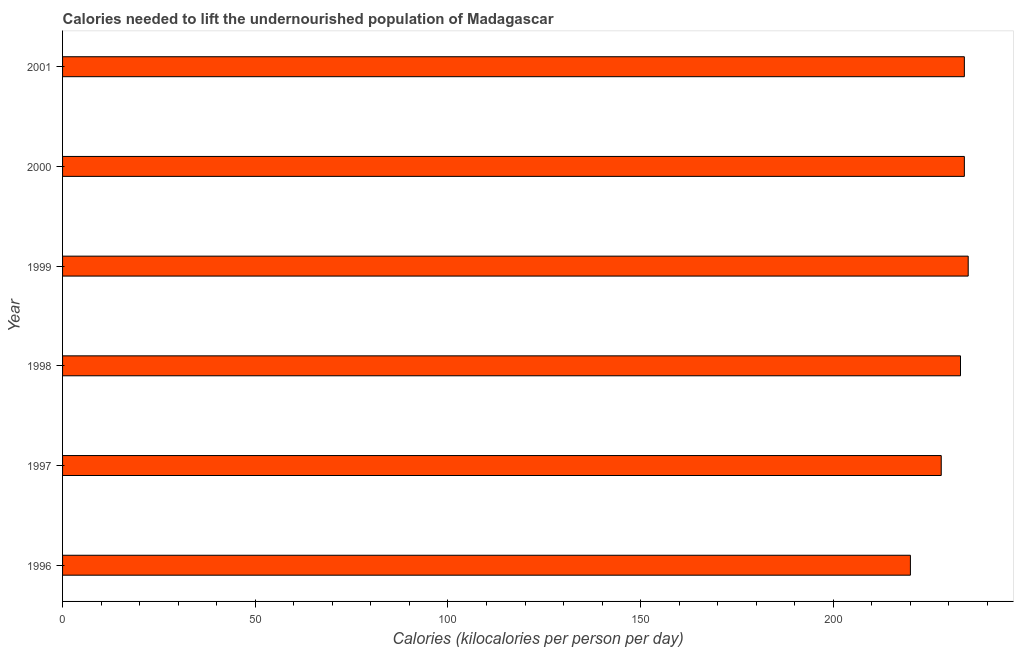Does the graph contain grids?
Your answer should be very brief. No. What is the title of the graph?
Ensure brevity in your answer.  Calories needed to lift the undernourished population of Madagascar. What is the label or title of the X-axis?
Your answer should be very brief. Calories (kilocalories per person per day). What is the depth of food deficit in 1996?
Provide a short and direct response. 220. Across all years, what is the maximum depth of food deficit?
Offer a very short reply. 235. Across all years, what is the minimum depth of food deficit?
Ensure brevity in your answer.  220. In which year was the depth of food deficit minimum?
Make the answer very short. 1996. What is the sum of the depth of food deficit?
Provide a succinct answer. 1384. What is the average depth of food deficit per year?
Give a very brief answer. 230. What is the median depth of food deficit?
Offer a very short reply. 233.5. Do a majority of the years between 2000 and 1997 (inclusive) have depth of food deficit greater than 20 kilocalories?
Offer a terse response. Yes. Is the depth of food deficit in 1996 less than that in 1998?
Offer a terse response. Yes. Is the difference between the depth of food deficit in 1996 and 1998 greater than the difference between any two years?
Your answer should be very brief. No. Is the sum of the depth of food deficit in 1996 and 1997 greater than the maximum depth of food deficit across all years?
Your answer should be compact. Yes. What is the difference between the highest and the lowest depth of food deficit?
Your answer should be very brief. 15. In how many years, is the depth of food deficit greater than the average depth of food deficit taken over all years?
Keep it short and to the point. 4. How many years are there in the graph?
Provide a succinct answer. 6. What is the difference between two consecutive major ticks on the X-axis?
Offer a terse response. 50. Are the values on the major ticks of X-axis written in scientific E-notation?
Give a very brief answer. No. What is the Calories (kilocalories per person per day) in 1996?
Make the answer very short. 220. What is the Calories (kilocalories per person per day) of 1997?
Your answer should be very brief. 228. What is the Calories (kilocalories per person per day) of 1998?
Provide a short and direct response. 233. What is the Calories (kilocalories per person per day) of 1999?
Provide a short and direct response. 235. What is the Calories (kilocalories per person per day) of 2000?
Ensure brevity in your answer.  234. What is the Calories (kilocalories per person per day) of 2001?
Keep it short and to the point. 234. What is the difference between the Calories (kilocalories per person per day) in 1996 and 1999?
Offer a terse response. -15. What is the difference between the Calories (kilocalories per person per day) in 1996 and 2000?
Your response must be concise. -14. What is the difference between the Calories (kilocalories per person per day) in 1997 and 1998?
Offer a terse response. -5. What is the difference between the Calories (kilocalories per person per day) in 1997 and 1999?
Give a very brief answer. -7. What is the difference between the Calories (kilocalories per person per day) in 1997 and 2001?
Your answer should be compact. -6. What is the difference between the Calories (kilocalories per person per day) in 1998 and 1999?
Provide a succinct answer. -2. What is the difference between the Calories (kilocalories per person per day) in 1998 and 2001?
Offer a terse response. -1. What is the difference between the Calories (kilocalories per person per day) in 2000 and 2001?
Ensure brevity in your answer.  0. What is the ratio of the Calories (kilocalories per person per day) in 1996 to that in 1997?
Provide a short and direct response. 0.96. What is the ratio of the Calories (kilocalories per person per day) in 1996 to that in 1998?
Ensure brevity in your answer.  0.94. What is the ratio of the Calories (kilocalories per person per day) in 1996 to that in 1999?
Offer a very short reply. 0.94. What is the ratio of the Calories (kilocalories per person per day) in 1997 to that in 1998?
Your response must be concise. 0.98. What is the ratio of the Calories (kilocalories per person per day) in 1997 to that in 2001?
Ensure brevity in your answer.  0.97. What is the ratio of the Calories (kilocalories per person per day) in 1998 to that in 1999?
Offer a very short reply. 0.99. What is the ratio of the Calories (kilocalories per person per day) in 1999 to that in 2000?
Your answer should be compact. 1. What is the ratio of the Calories (kilocalories per person per day) in 2000 to that in 2001?
Ensure brevity in your answer.  1. 